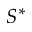<formula> <loc_0><loc_0><loc_500><loc_500>S ^ { * }</formula> 